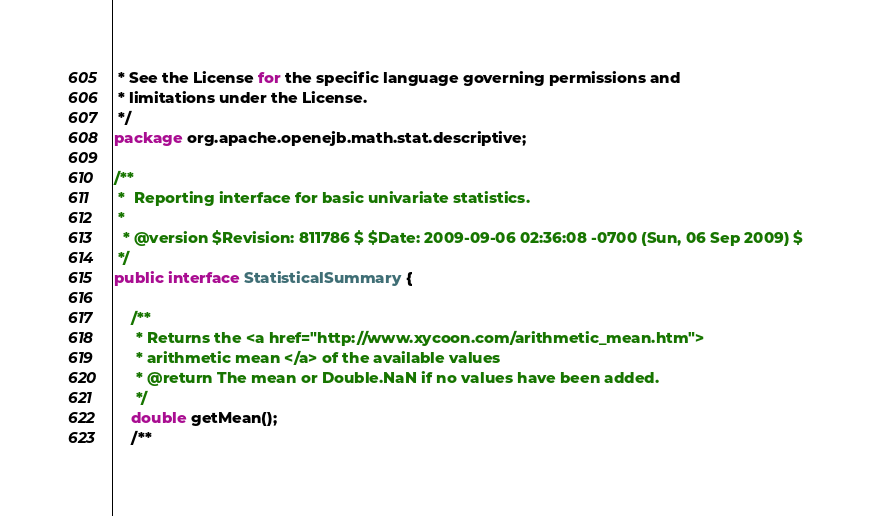Convert code to text. <code><loc_0><loc_0><loc_500><loc_500><_Java_> * See the License for the specific language governing permissions and
 * limitations under the License.
 */
package org.apache.openejb.math.stat.descriptive;

/**
 *  Reporting interface for basic univariate statistics.
 *
  * @version $Revision: 811786 $ $Date: 2009-09-06 02:36:08 -0700 (Sun, 06 Sep 2009) $
 */
public interface StatisticalSummary {

    /**
     * Returns the <a href="http://www.xycoon.com/arithmetic_mean.htm">
     * arithmetic mean </a> of the available values
     * @return The mean or Double.NaN if no values have been added.
     */
    double getMean();
    /**</code> 